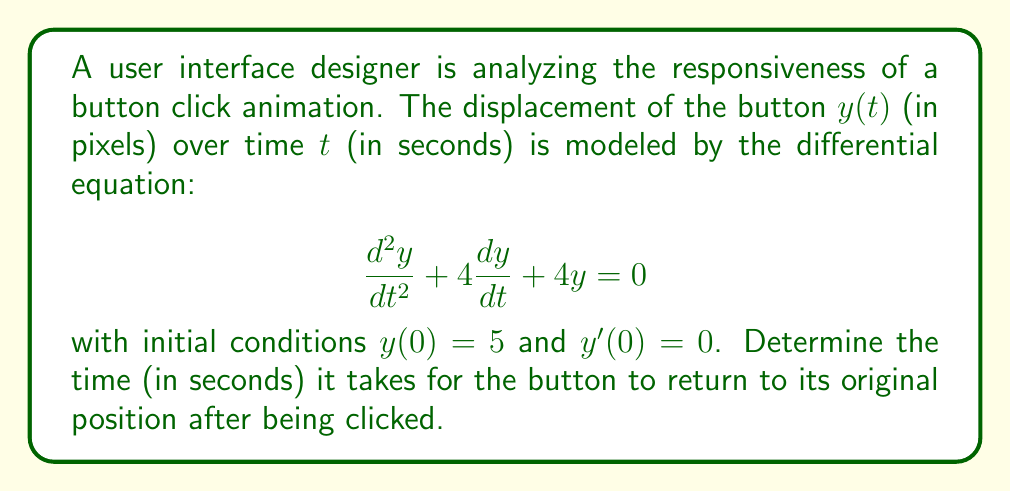Help me with this question. To solve this problem, we'll follow these steps:

1) The given differential equation is a second-order linear homogeneous equation with constant coefficients. Its characteristic equation is:

   $$r^2 + 4r + 4 = 0$$

2) Solving this quadratic equation:
   $$(r + 2)^2 = 0$$
   $$r = -2$$ (double root)

3) The general solution for a double root is:
   $$y(t) = (C_1 + C_2t)e^{-2t}$$

4) Using the initial conditions to find $C_1$ and $C_2$:
   
   For $y(0) = 5$:
   $$5 = C_1$$

   For $y'(0) = 0$:
   $$y'(t) = (-2C_1 - 2C_2t + C_2)e^{-2t}$$
   $$0 = -2C_1 + C_2$$
   $$C_2 = 2C_1 = 10$$

5) Therefore, the particular solution is:
   $$y(t) = (5 + 10t)e^{-2t}$$

6) To find when the button returns to its original position, we need to solve:
   $$y(t) = 0$$
   $$(5 + 10t)e^{-2t} = 0$$

7) Since $e^{-2t}$ is never zero, we solve:
   $$5 + 10t = 0$$
   $$t = -\frac{1}{2}$$

8) However, time cannot be negative in this context. The button will asymptotically approach its original position but never quite reach it. We can consider it "returned" when it's within, say, 0.01 pixels of the original position.

9) Solving $|(5 + 10t)e^{-2t}| < 0.01$ numerically (which can be done using various methods like Newton's method or bisection), we get $t \approx 1.27$ seconds.
Answer: $1.27$ seconds (approximate) 